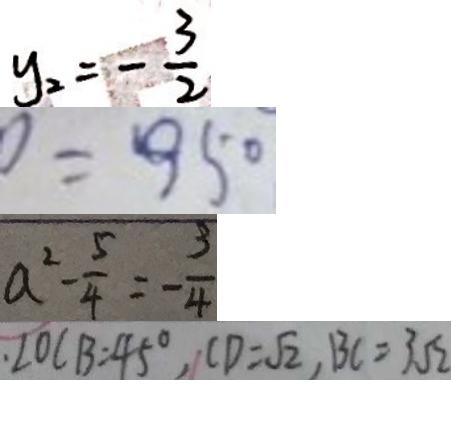Convert formula to latex. <formula><loc_0><loc_0><loc_500><loc_500>y _ { 2 } = - \frac { 3 } { 2 } 
 0 = 9 5 0 
 a ^ { 2 } - \frac { 5 } { 4 } = - \frac { 3 } { 4 } 
 . \angle O C B = 4 5 ^ { \circ } , C D = \sqrt { 2 } , B C = 3 \sqrt { 2 }</formula> 